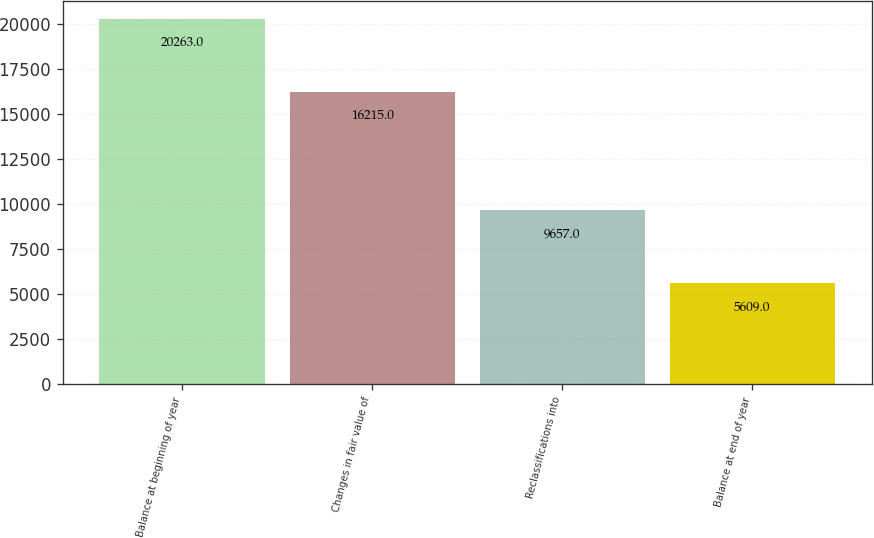Convert chart to OTSL. <chart><loc_0><loc_0><loc_500><loc_500><bar_chart><fcel>Balance at beginning of year<fcel>Changes in fair value of<fcel>Reclassifications into<fcel>Balance at end of year<nl><fcel>20263<fcel>16215<fcel>9657<fcel>5609<nl></chart> 